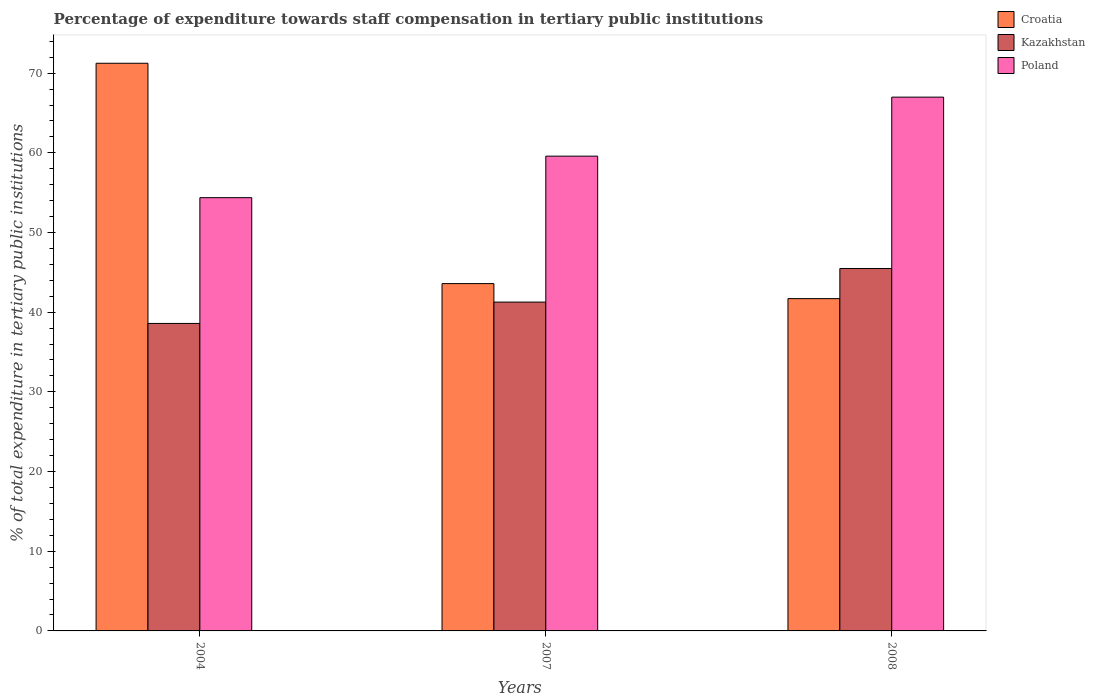How many different coloured bars are there?
Provide a short and direct response. 3. Are the number of bars on each tick of the X-axis equal?
Make the answer very short. Yes. How many bars are there on the 2nd tick from the left?
Provide a short and direct response. 3. How many bars are there on the 3rd tick from the right?
Provide a short and direct response. 3. What is the percentage of expenditure towards staff compensation in Croatia in 2008?
Make the answer very short. 41.7. Across all years, what is the maximum percentage of expenditure towards staff compensation in Kazakhstan?
Make the answer very short. 45.48. Across all years, what is the minimum percentage of expenditure towards staff compensation in Kazakhstan?
Your answer should be compact. 38.59. In which year was the percentage of expenditure towards staff compensation in Poland minimum?
Offer a very short reply. 2004. What is the total percentage of expenditure towards staff compensation in Poland in the graph?
Your response must be concise. 180.94. What is the difference between the percentage of expenditure towards staff compensation in Croatia in 2004 and that in 2007?
Make the answer very short. 27.65. What is the difference between the percentage of expenditure towards staff compensation in Croatia in 2007 and the percentage of expenditure towards staff compensation in Kazakhstan in 2004?
Ensure brevity in your answer.  5. What is the average percentage of expenditure towards staff compensation in Croatia per year?
Your answer should be very brief. 52.18. In the year 2008, what is the difference between the percentage of expenditure towards staff compensation in Croatia and percentage of expenditure towards staff compensation in Poland?
Your answer should be compact. -25.28. What is the ratio of the percentage of expenditure towards staff compensation in Kazakhstan in 2004 to that in 2008?
Give a very brief answer. 0.85. Is the percentage of expenditure towards staff compensation in Croatia in 2007 less than that in 2008?
Provide a short and direct response. No. Is the difference between the percentage of expenditure towards staff compensation in Croatia in 2004 and 2007 greater than the difference between the percentage of expenditure towards staff compensation in Poland in 2004 and 2007?
Keep it short and to the point. Yes. What is the difference between the highest and the second highest percentage of expenditure towards staff compensation in Kazakhstan?
Make the answer very short. 4.22. What is the difference between the highest and the lowest percentage of expenditure towards staff compensation in Kazakhstan?
Your response must be concise. 6.89. What does the 2nd bar from the left in 2007 represents?
Offer a terse response. Kazakhstan. What does the 3rd bar from the right in 2008 represents?
Your answer should be compact. Croatia. How many years are there in the graph?
Ensure brevity in your answer.  3. What is the difference between two consecutive major ticks on the Y-axis?
Your answer should be very brief. 10. Are the values on the major ticks of Y-axis written in scientific E-notation?
Provide a short and direct response. No. Does the graph contain any zero values?
Make the answer very short. No. How are the legend labels stacked?
Ensure brevity in your answer.  Vertical. What is the title of the graph?
Your response must be concise. Percentage of expenditure towards staff compensation in tertiary public institutions. What is the label or title of the Y-axis?
Make the answer very short. % of total expenditure in tertiary public institutions. What is the % of total expenditure in tertiary public institutions in Croatia in 2004?
Keep it short and to the point. 71.24. What is the % of total expenditure in tertiary public institutions of Kazakhstan in 2004?
Your response must be concise. 38.59. What is the % of total expenditure in tertiary public institutions of Poland in 2004?
Give a very brief answer. 54.37. What is the % of total expenditure in tertiary public institutions in Croatia in 2007?
Your answer should be very brief. 43.59. What is the % of total expenditure in tertiary public institutions in Kazakhstan in 2007?
Ensure brevity in your answer.  41.27. What is the % of total expenditure in tertiary public institutions in Poland in 2007?
Provide a short and direct response. 59.58. What is the % of total expenditure in tertiary public institutions of Croatia in 2008?
Provide a succinct answer. 41.7. What is the % of total expenditure in tertiary public institutions in Kazakhstan in 2008?
Give a very brief answer. 45.48. What is the % of total expenditure in tertiary public institutions in Poland in 2008?
Keep it short and to the point. 66.99. Across all years, what is the maximum % of total expenditure in tertiary public institutions in Croatia?
Offer a terse response. 71.24. Across all years, what is the maximum % of total expenditure in tertiary public institutions of Kazakhstan?
Your answer should be very brief. 45.48. Across all years, what is the maximum % of total expenditure in tertiary public institutions of Poland?
Your response must be concise. 66.99. Across all years, what is the minimum % of total expenditure in tertiary public institutions in Croatia?
Give a very brief answer. 41.7. Across all years, what is the minimum % of total expenditure in tertiary public institutions in Kazakhstan?
Offer a terse response. 38.59. Across all years, what is the minimum % of total expenditure in tertiary public institutions of Poland?
Give a very brief answer. 54.37. What is the total % of total expenditure in tertiary public institutions of Croatia in the graph?
Your answer should be compact. 156.53. What is the total % of total expenditure in tertiary public institutions of Kazakhstan in the graph?
Ensure brevity in your answer.  125.34. What is the total % of total expenditure in tertiary public institutions in Poland in the graph?
Your answer should be very brief. 180.94. What is the difference between the % of total expenditure in tertiary public institutions in Croatia in 2004 and that in 2007?
Provide a succinct answer. 27.65. What is the difference between the % of total expenditure in tertiary public institutions of Kazakhstan in 2004 and that in 2007?
Your response must be concise. -2.68. What is the difference between the % of total expenditure in tertiary public institutions in Poland in 2004 and that in 2007?
Ensure brevity in your answer.  -5.21. What is the difference between the % of total expenditure in tertiary public institutions in Croatia in 2004 and that in 2008?
Make the answer very short. 29.54. What is the difference between the % of total expenditure in tertiary public institutions of Kazakhstan in 2004 and that in 2008?
Make the answer very short. -6.89. What is the difference between the % of total expenditure in tertiary public institutions of Poland in 2004 and that in 2008?
Offer a very short reply. -12.61. What is the difference between the % of total expenditure in tertiary public institutions of Croatia in 2007 and that in 2008?
Provide a short and direct response. 1.88. What is the difference between the % of total expenditure in tertiary public institutions in Kazakhstan in 2007 and that in 2008?
Your response must be concise. -4.22. What is the difference between the % of total expenditure in tertiary public institutions in Poland in 2007 and that in 2008?
Ensure brevity in your answer.  -7.41. What is the difference between the % of total expenditure in tertiary public institutions of Croatia in 2004 and the % of total expenditure in tertiary public institutions of Kazakhstan in 2007?
Give a very brief answer. 29.97. What is the difference between the % of total expenditure in tertiary public institutions in Croatia in 2004 and the % of total expenditure in tertiary public institutions in Poland in 2007?
Provide a succinct answer. 11.66. What is the difference between the % of total expenditure in tertiary public institutions in Kazakhstan in 2004 and the % of total expenditure in tertiary public institutions in Poland in 2007?
Your answer should be very brief. -20.99. What is the difference between the % of total expenditure in tertiary public institutions of Croatia in 2004 and the % of total expenditure in tertiary public institutions of Kazakhstan in 2008?
Give a very brief answer. 25.76. What is the difference between the % of total expenditure in tertiary public institutions in Croatia in 2004 and the % of total expenditure in tertiary public institutions in Poland in 2008?
Your answer should be compact. 4.25. What is the difference between the % of total expenditure in tertiary public institutions of Kazakhstan in 2004 and the % of total expenditure in tertiary public institutions of Poland in 2008?
Provide a succinct answer. -28.4. What is the difference between the % of total expenditure in tertiary public institutions of Croatia in 2007 and the % of total expenditure in tertiary public institutions of Kazakhstan in 2008?
Keep it short and to the point. -1.9. What is the difference between the % of total expenditure in tertiary public institutions of Croatia in 2007 and the % of total expenditure in tertiary public institutions of Poland in 2008?
Keep it short and to the point. -23.4. What is the difference between the % of total expenditure in tertiary public institutions in Kazakhstan in 2007 and the % of total expenditure in tertiary public institutions in Poland in 2008?
Your response must be concise. -25.72. What is the average % of total expenditure in tertiary public institutions of Croatia per year?
Provide a succinct answer. 52.18. What is the average % of total expenditure in tertiary public institutions in Kazakhstan per year?
Ensure brevity in your answer.  41.78. What is the average % of total expenditure in tertiary public institutions in Poland per year?
Offer a very short reply. 60.31. In the year 2004, what is the difference between the % of total expenditure in tertiary public institutions of Croatia and % of total expenditure in tertiary public institutions of Kazakhstan?
Your answer should be compact. 32.65. In the year 2004, what is the difference between the % of total expenditure in tertiary public institutions of Croatia and % of total expenditure in tertiary public institutions of Poland?
Provide a succinct answer. 16.87. In the year 2004, what is the difference between the % of total expenditure in tertiary public institutions of Kazakhstan and % of total expenditure in tertiary public institutions of Poland?
Provide a short and direct response. -15.78. In the year 2007, what is the difference between the % of total expenditure in tertiary public institutions in Croatia and % of total expenditure in tertiary public institutions in Kazakhstan?
Provide a succinct answer. 2.32. In the year 2007, what is the difference between the % of total expenditure in tertiary public institutions in Croatia and % of total expenditure in tertiary public institutions in Poland?
Your response must be concise. -15.99. In the year 2007, what is the difference between the % of total expenditure in tertiary public institutions of Kazakhstan and % of total expenditure in tertiary public institutions of Poland?
Your response must be concise. -18.31. In the year 2008, what is the difference between the % of total expenditure in tertiary public institutions in Croatia and % of total expenditure in tertiary public institutions in Kazakhstan?
Keep it short and to the point. -3.78. In the year 2008, what is the difference between the % of total expenditure in tertiary public institutions of Croatia and % of total expenditure in tertiary public institutions of Poland?
Give a very brief answer. -25.28. In the year 2008, what is the difference between the % of total expenditure in tertiary public institutions in Kazakhstan and % of total expenditure in tertiary public institutions in Poland?
Offer a very short reply. -21.5. What is the ratio of the % of total expenditure in tertiary public institutions in Croatia in 2004 to that in 2007?
Provide a succinct answer. 1.63. What is the ratio of the % of total expenditure in tertiary public institutions of Kazakhstan in 2004 to that in 2007?
Your answer should be compact. 0.94. What is the ratio of the % of total expenditure in tertiary public institutions in Poland in 2004 to that in 2007?
Your answer should be very brief. 0.91. What is the ratio of the % of total expenditure in tertiary public institutions in Croatia in 2004 to that in 2008?
Your answer should be very brief. 1.71. What is the ratio of the % of total expenditure in tertiary public institutions of Kazakhstan in 2004 to that in 2008?
Your answer should be very brief. 0.85. What is the ratio of the % of total expenditure in tertiary public institutions in Poland in 2004 to that in 2008?
Provide a succinct answer. 0.81. What is the ratio of the % of total expenditure in tertiary public institutions of Croatia in 2007 to that in 2008?
Your response must be concise. 1.05. What is the ratio of the % of total expenditure in tertiary public institutions of Kazakhstan in 2007 to that in 2008?
Ensure brevity in your answer.  0.91. What is the ratio of the % of total expenditure in tertiary public institutions in Poland in 2007 to that in 2008?
Give a very brief answer. 0.89. What is the difference between the highest and the second highest % of total expenditure in tertiary public institutions in Croatia?
Provide a short and direct response. 27.65. What is the difference between the highest and the second highest % of total expenditure in tertiary public institutions in Kazakhstan?
Your response must be concise. 4.22. What is the difference between the highest and the second highest % of total expenditure in tertiary public institutions in Poland?
Keep it short and to the point. 7.41. What is the difference between the highest and the lowest % of total expenditure in tertiary public institutions in Croatia?
Ensure brevity in your answer.  29.54. What is the difference between the highest and the lowest % of total expenditure in tertiary public institutions in Kazakhstan?
Keep it short and to the point. 6.89. What is the difference between the highest and the lowest % of total expenditure in tertiary public institutions in Poland?
Keep it short and to the point. 12.61. 